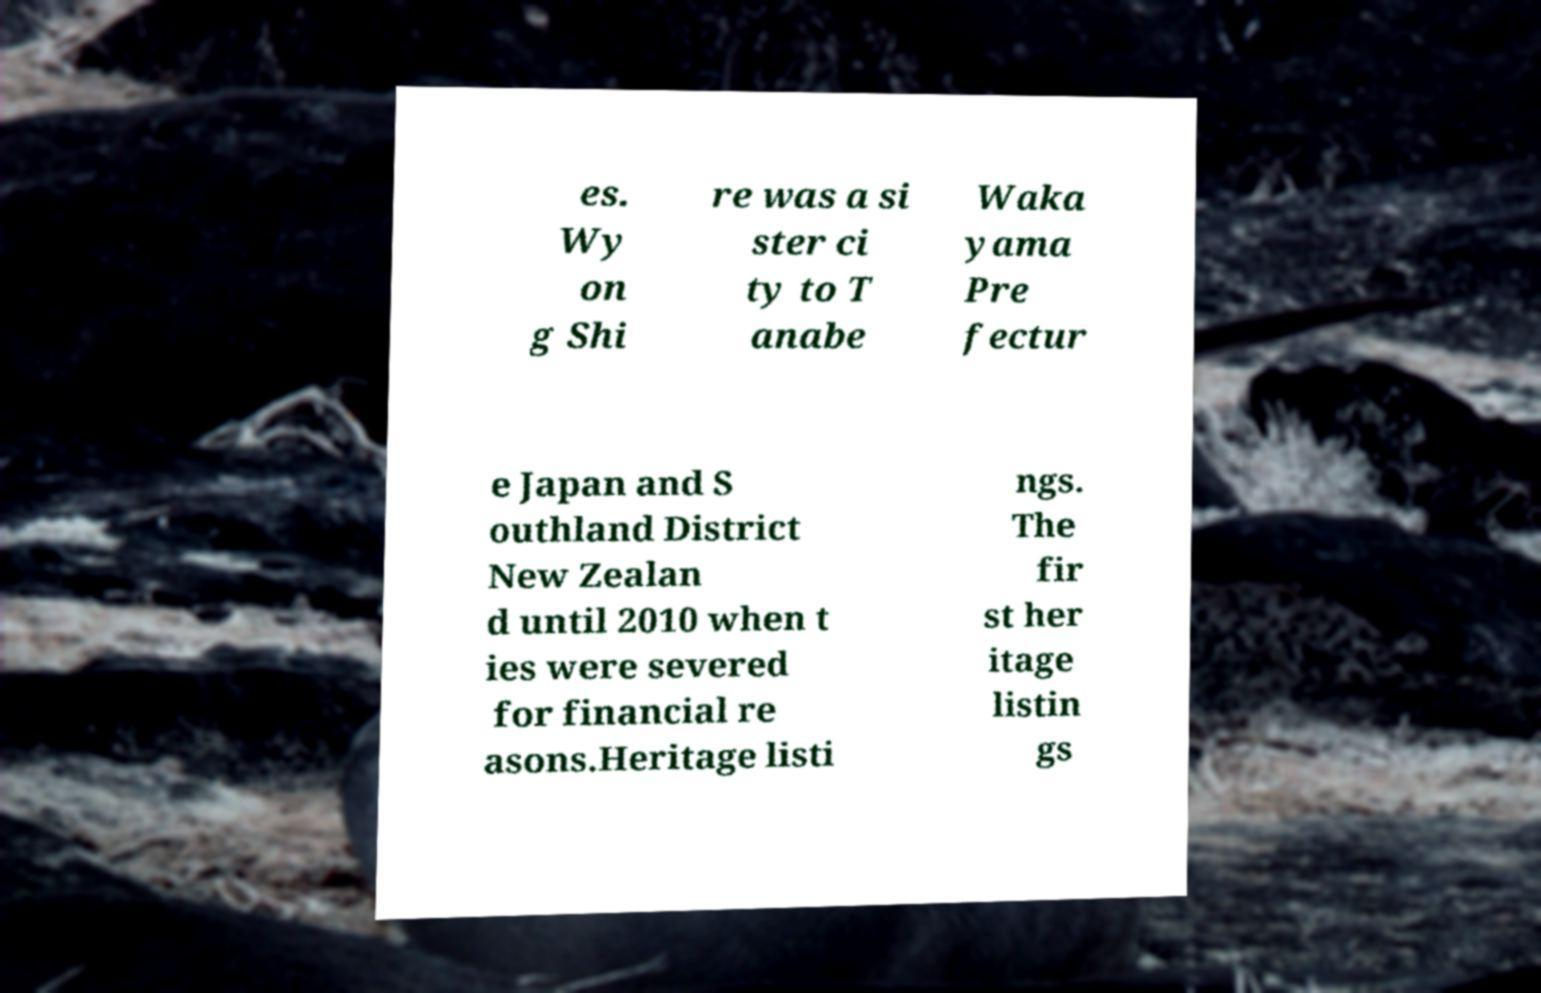There's text embedded in this image that I need extracted. Can you transcribe it verbatim? es. Wy on g Shi re was a si ster ci ty to T anabe Waka yama Pre fectur e Japan and S outhland District New Zealan d until 2010 when t ies were severed for financial re asons.Heritage listi ngs. The fir st her itage listin gs 